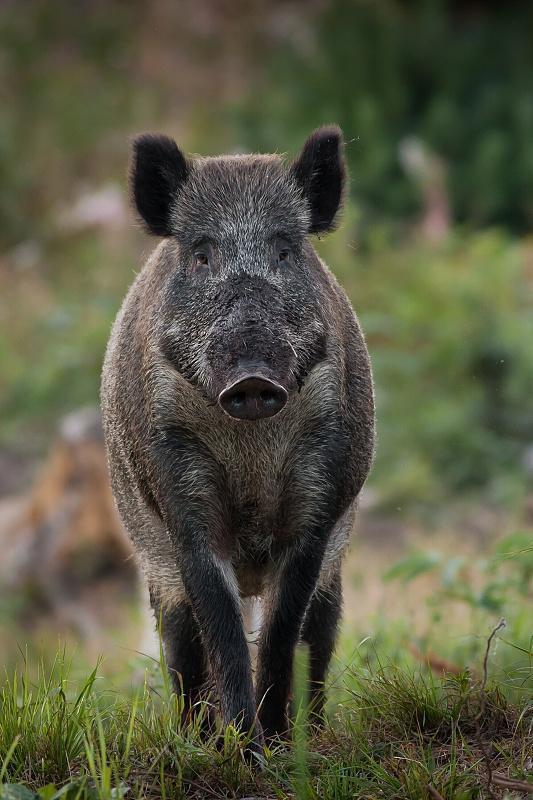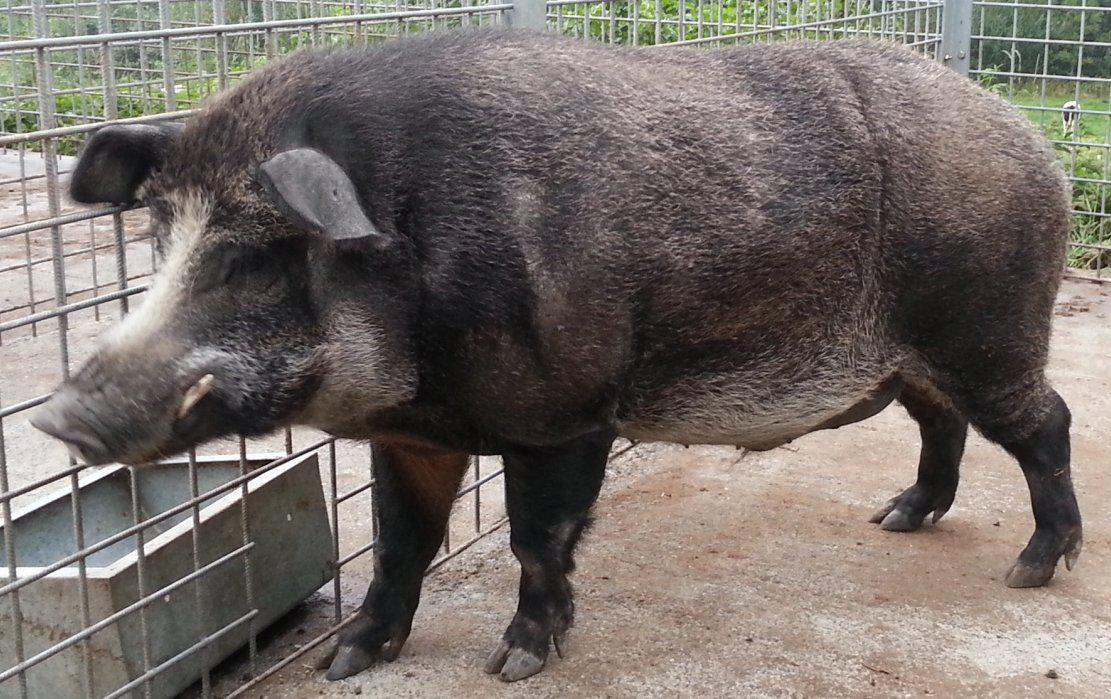The first image is the image on the left, the second image is the image on the right. For the images displayed, is the sentence "The animal in the image on the left has its body turned to the right." factually correct? Answer yes or no. No. 